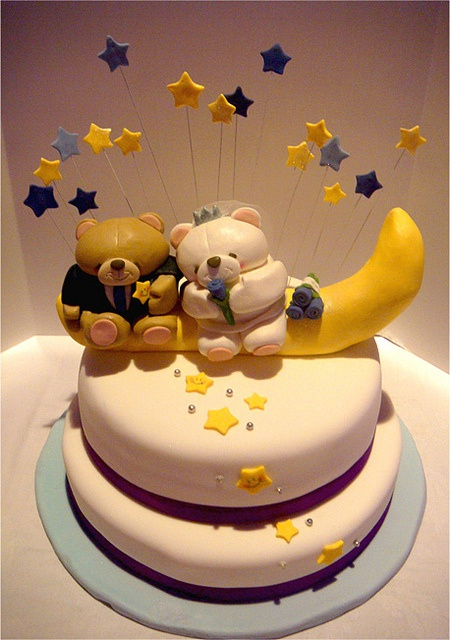Describe the objects in this image and their specific colors. I can see cake in darkgray, tan, olive, gray, and orange tones, teddy bear in darkgray, tan, and brown tones, teddy bear in darkgray, olive, black, maroon, and orange tones, and tie in black and darkgray tones in this image. 